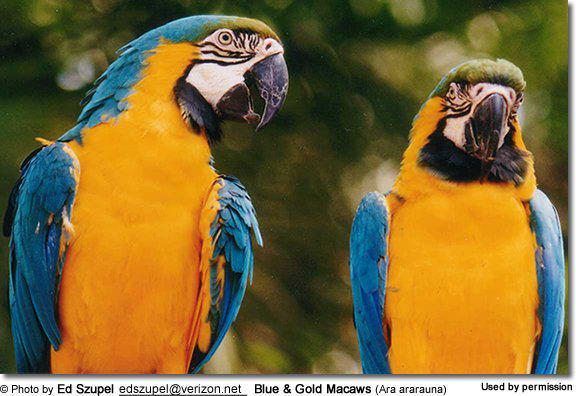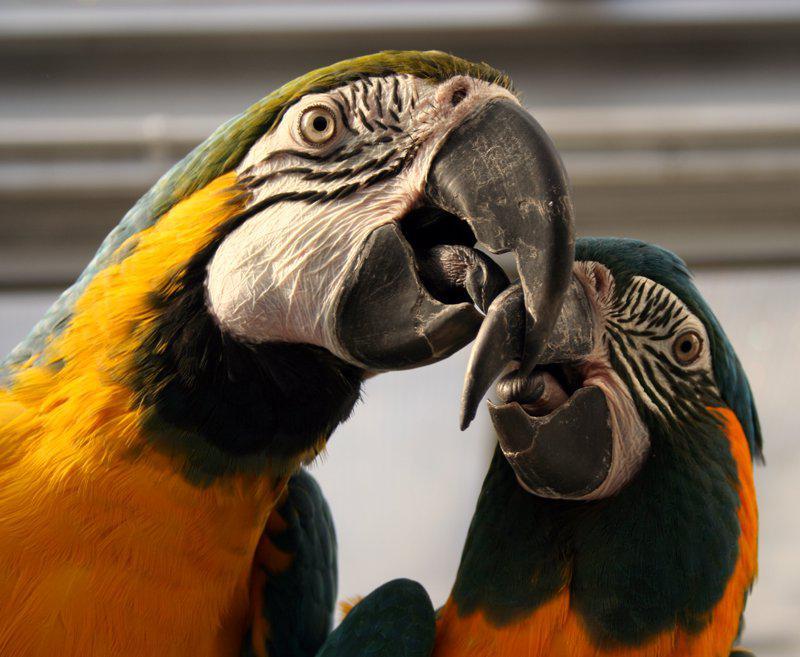The first image is the image on the left, the second image is the image on the right. Considering the images on both sides, is "There are two parrots." valid? Answer yes or no. No. The first image is the image on the left, the second image is the image on the right. For the images shown, is this caption "There is no more than one bird in each image." true? Answer yes or no. No. 